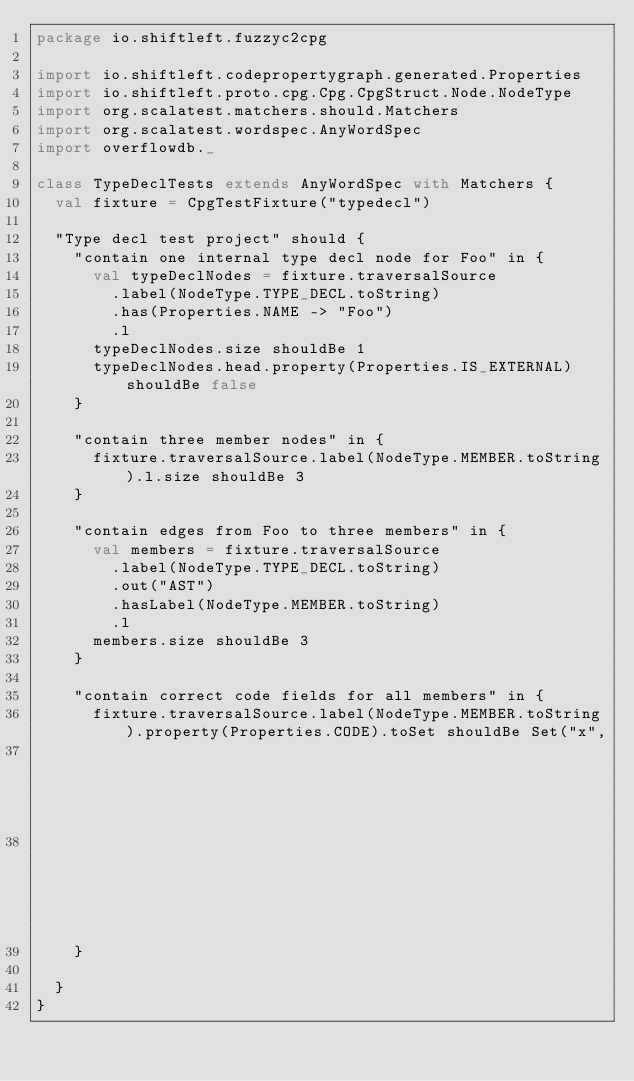Convert code to text. <code><loc_0><loc_0><loc_500><loc_500><_Scala_>package io.shiftleft.fuzzyc2cpg

import io.shiftleft.codepropertygraph.generated.Properties
import io.shiftleft.proto.cpg.Cpg.CpgStruct.Node.NodeType
import org.scalatest.matchers.should.Matchers
import org.scalatest.wordspec.AnyWordSpec
import overflowdb._

class TypeDeclTests extends AnyWordSpec with Matchers {
  val fixture = CpgTestFixture("typedecl")

  "Type decl test project" should {
    "contain one internal type decl node for Foo" in {
      val typeDeclNodes = fixture.traversalSource
        .label(NodeType.TYPE_DECL.toString)
        .has(Properties.NAME -> "Foo")
        .l
      typeDeclNodes.size shouldBe 1
      typeDeclNodes.head.property(Properties.IS_EXTERNAL) shouldBe false
    }

    "contain three member nodes" in {
      fixture.traversalSource.label(NodeType.MEMBER.toString).l.size shouldBe 3
    }

    "contain edges from Foo to three members" in {
      val members = fixture.traversalSource
        .label(NodeType.TYPE_DECL.toString)
        .out("AST")
        .hasLabel(NodeType.MEMBER.toString)
        .l
      members.size shouldBe 3
    }

    "contain correct code fields for all members" in {
      fixture.traversalSource.label(NodeType.MEMBER.toString).property(Properties.CODE).toSet shouldBe Set("x",
                                                                                                           "y",
                                                                                                           "*foo")
    }

  }
}
</code> 